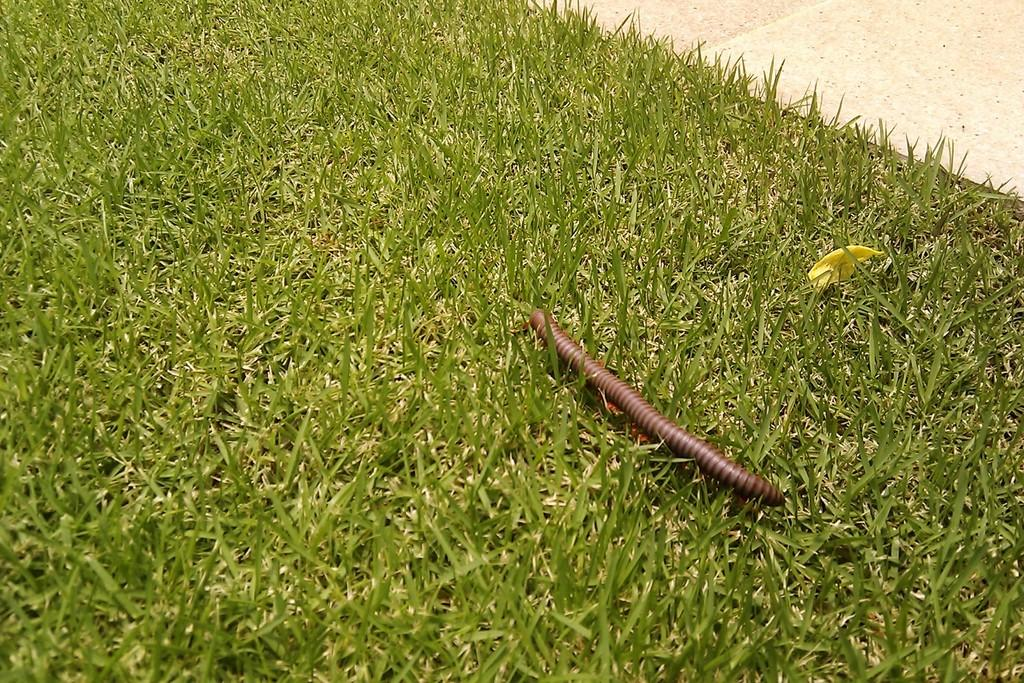What type of insect is present in the image? There is a millipedes insect in the image. What type of vegetation can be seen in the image? There is grass in the image. Can you describe any man-made structures in the image? There appears to be a pathway in the image. What type of drug is the millipedes using in the image? There is no drug present in the image, as it features a millipedes insect and its surroundings. 